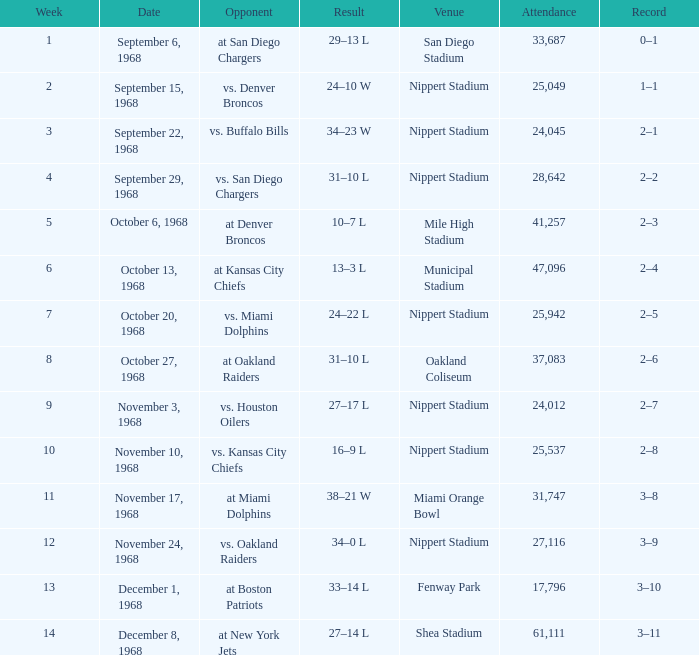What week was the game played at Mile High Stadium? 5.0. 